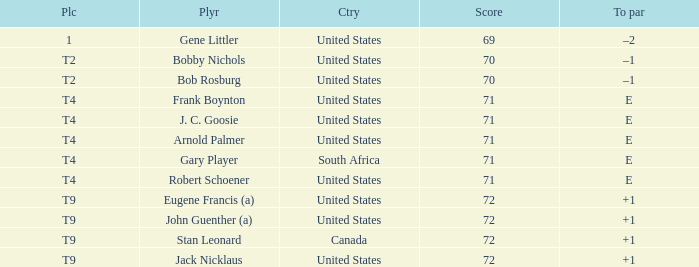What is To Par, when Country is "United States", when Place is "T4", and when Player is "Frank Boynton"? E. 